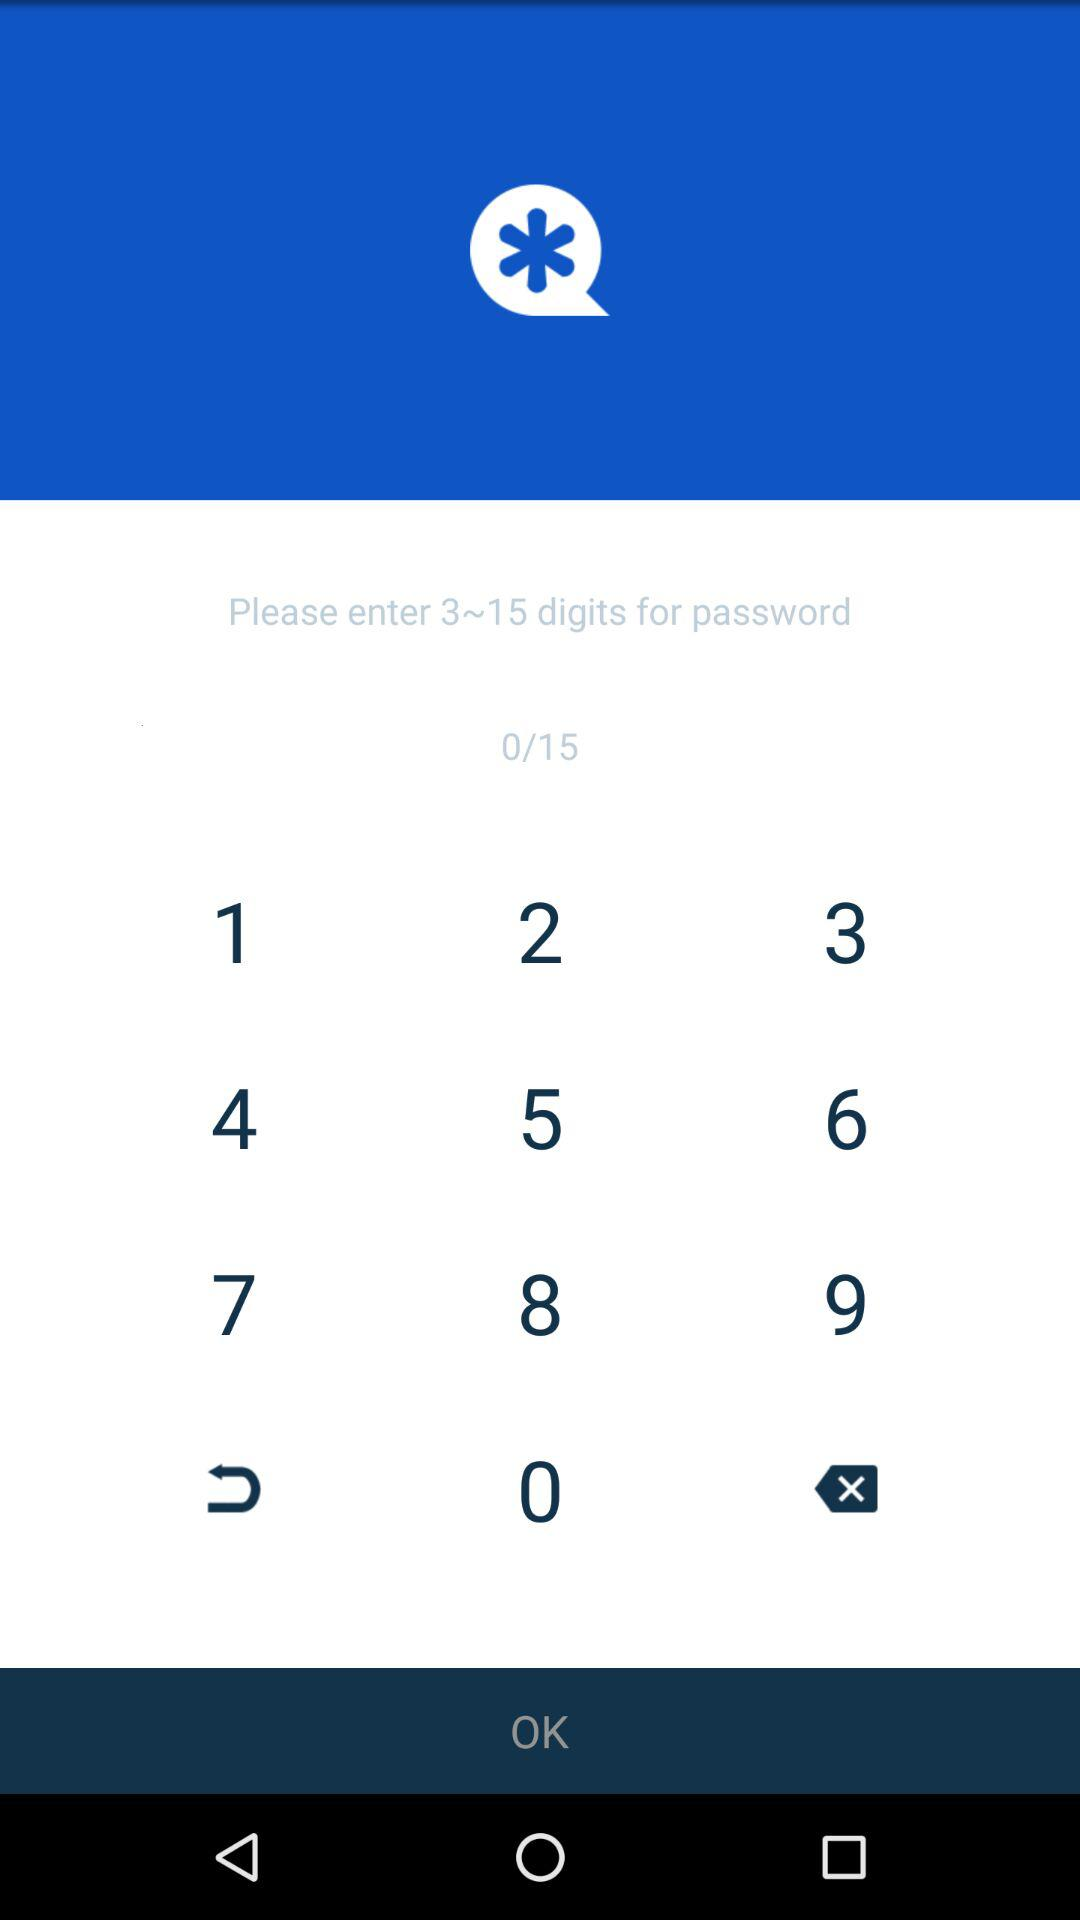How many digits is the entered password?
When the provided information is insufficient, respond with <no answer>. <no answer> 